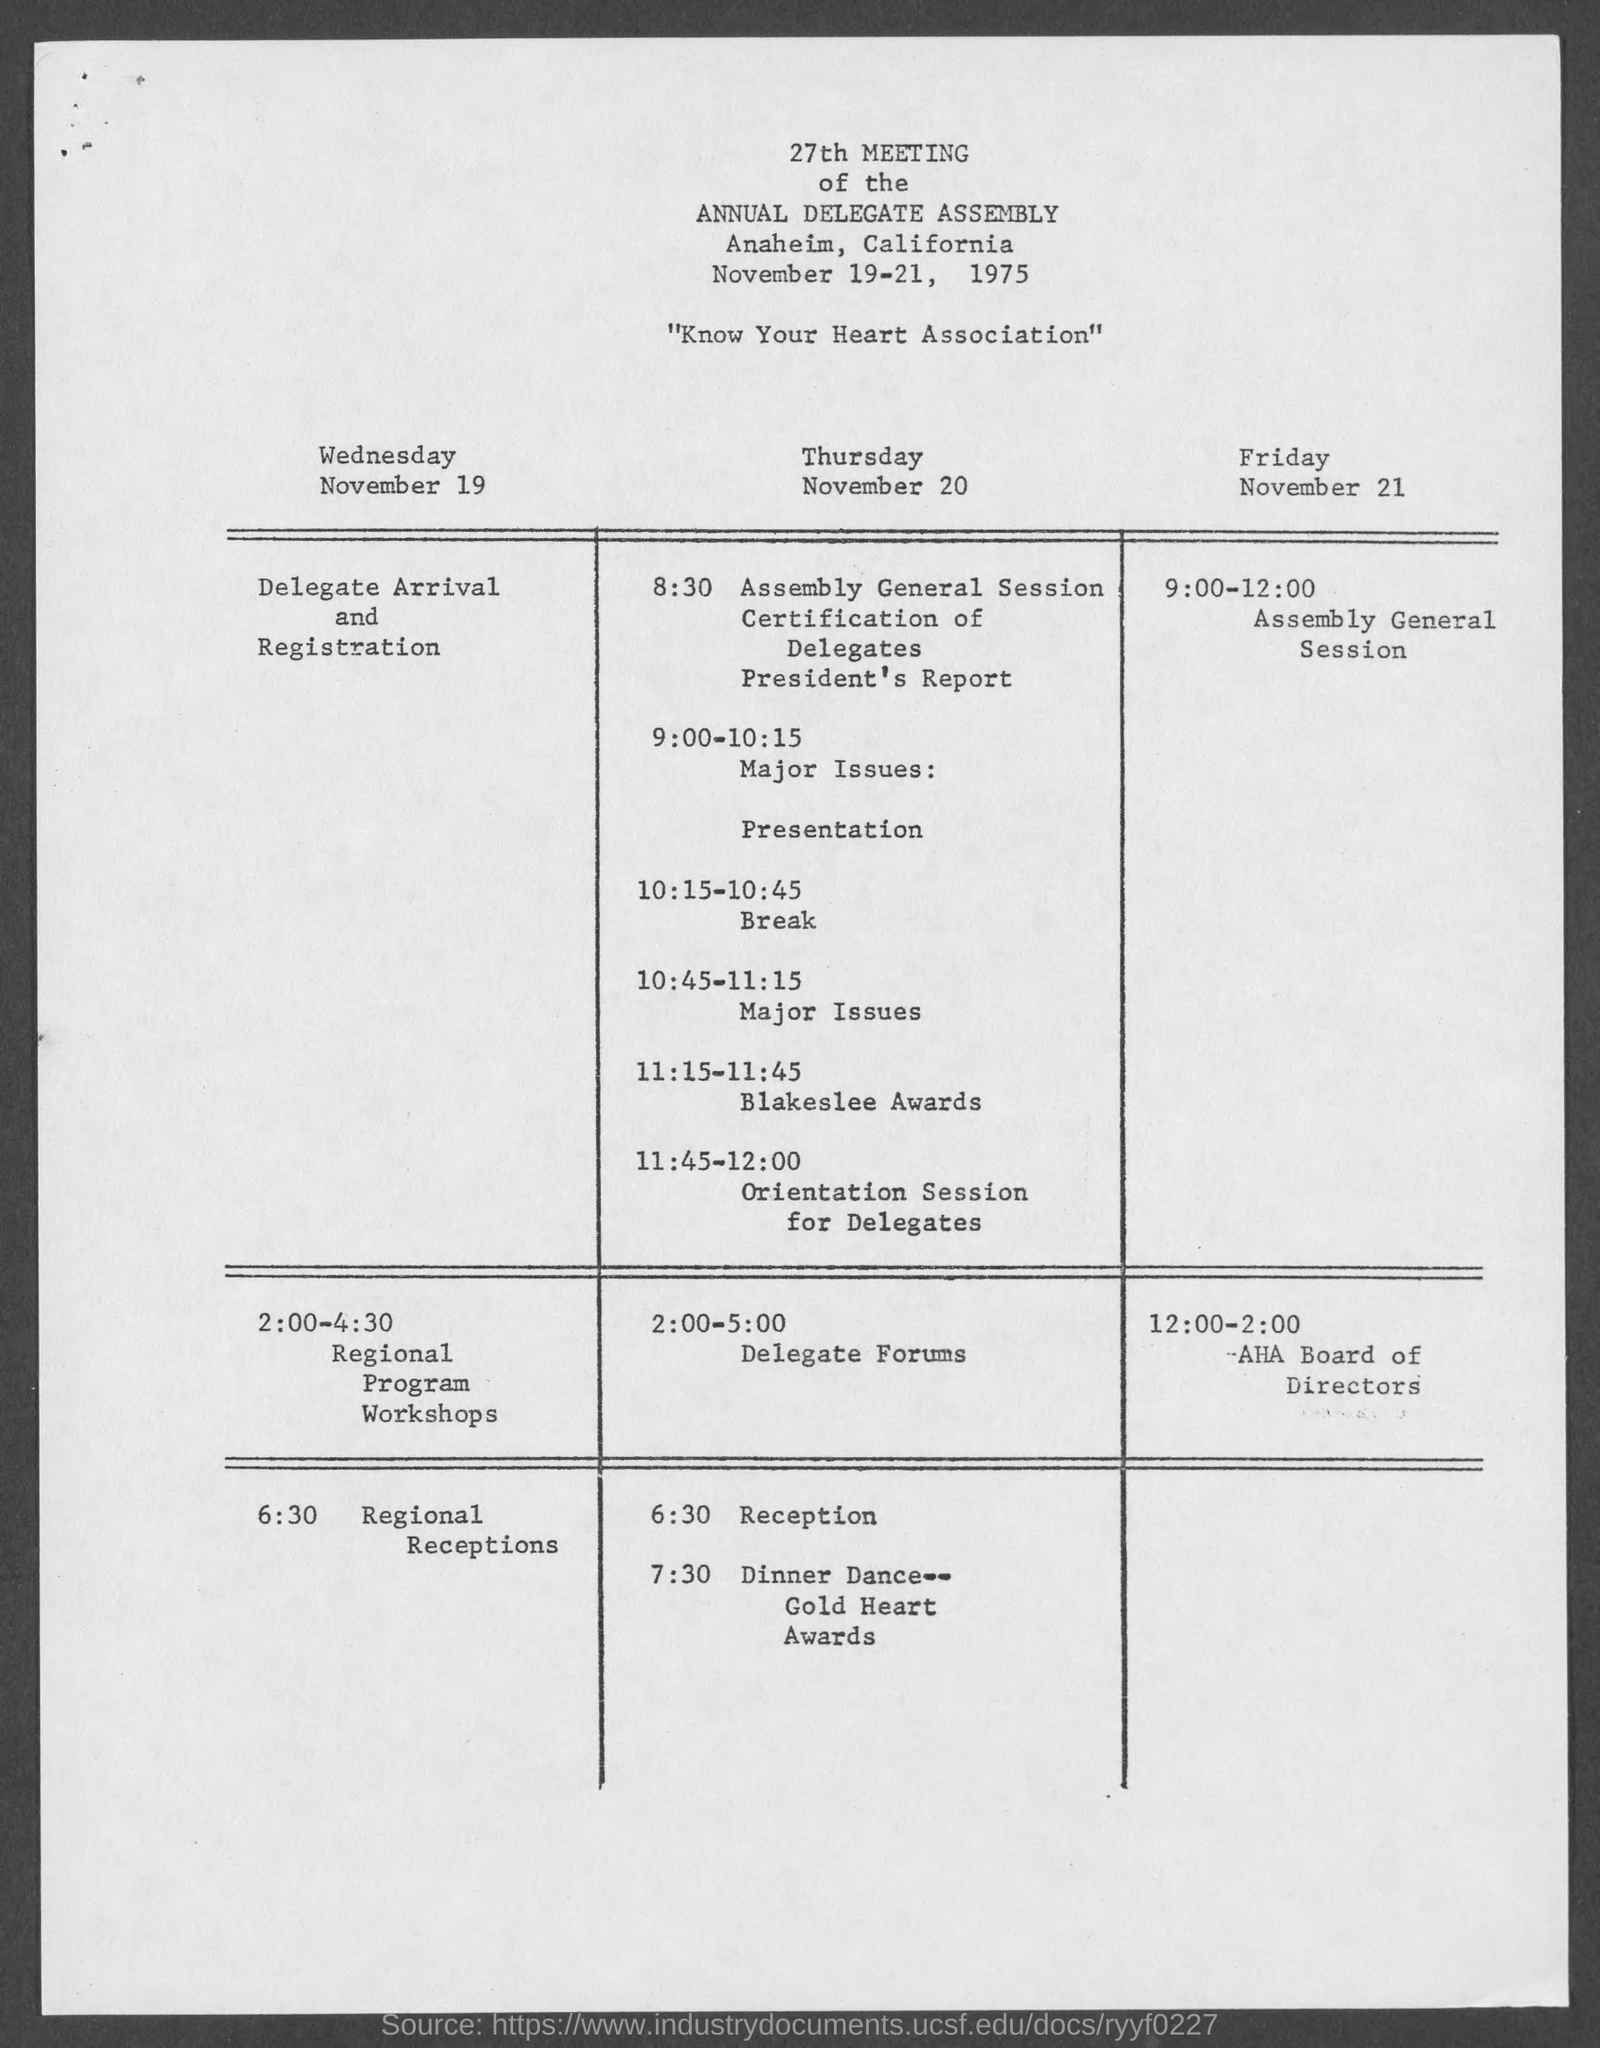Outline some significant characteristics in this image. The Blakeslee Awards will take place on Thursday, November 20. The Gold Heart Awards will take place on Thursday. The registration will take place on Wednesday. The title of the document is "27th Meeting of the Annual Delegate Assembly. 